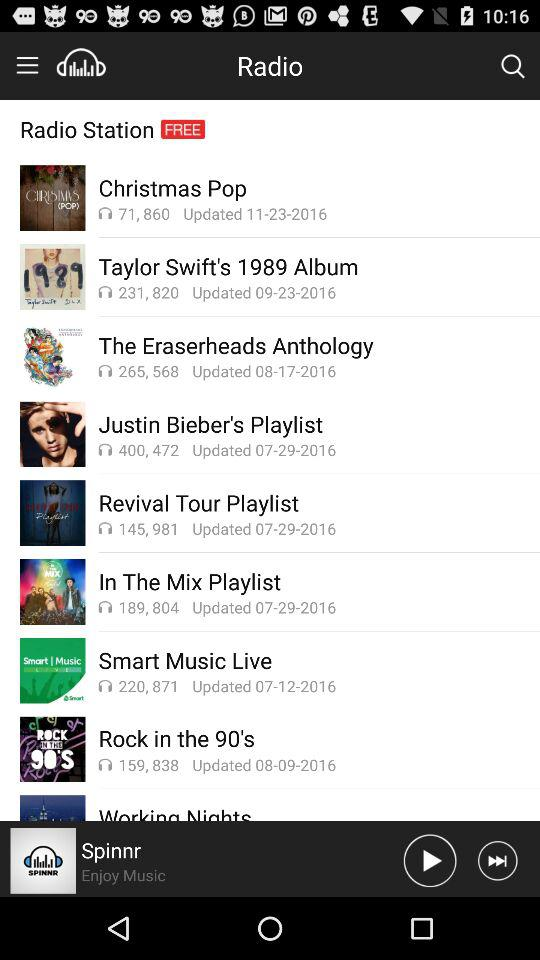Which radio station is playing? The playing radio station is "Spinnr". 